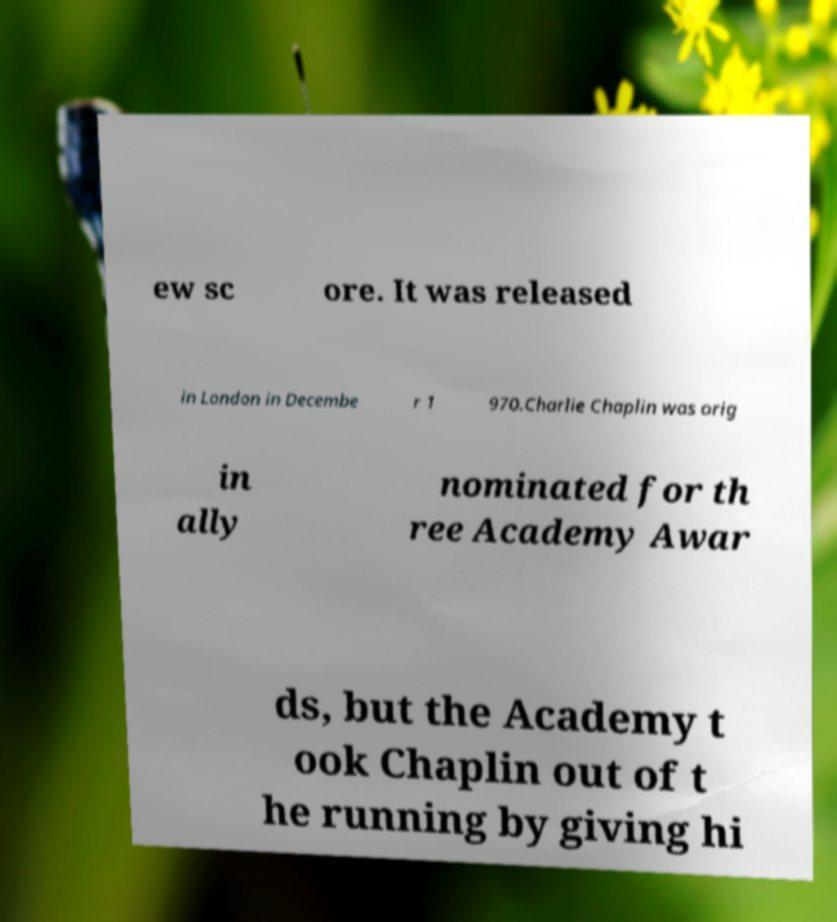What messages or text are displayed in this image? I need them in a readable, typed format. ew sc ore. It was released in London in Decembe r 1 970.Charlie Chaplin was orig in ally nominated for th ree Academy Awar ds, but the Academy t ook Chaplin out of t he running by giving hi 